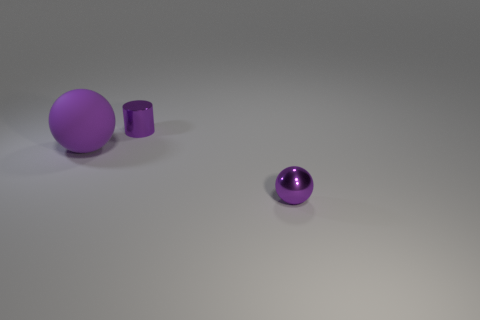Add 3 shiny objects. How many objects exist? 6 Subtract all balls. How many objects are left? 1 Subtract all large yellow rubber cylinders. Subtract all balls. How many objects are left? 1 Add 2 metallic spheres. How many metallic spheres are left? 3 Add 1 purple cylinders. How many purple cylinders exist? 2 Subtract 1 purple cylinders. How many objects are left? 2 